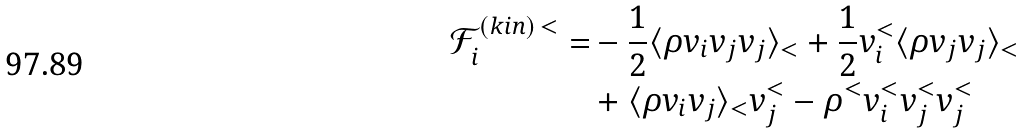Convert formula to latex. <formula><loc_0><loc_0><loc_500><loc_500>\mathcal { F } _ { i } ^ { ( k i n ) \, < } = & - \frac { 1 } { 2 } \langle \rho v _ { i } v _ { j } v _ { j } \rangle _ { < } + \frac { 1 } { 2 } v _ { i } ^ { < } \langle \rho v _ { j } v _ { j } \rangle _ { < } \\ & + \langle \rho v _ { i } v _ { j } \rangle _ { < } v _ { j } ^ { < } - \rho ^ { < } v _ { i } ^ { < } v _ { j } ^ { < } v _ { j } ^ { < } \\</formula> 